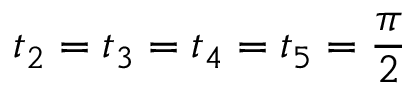Convert formula to latex. <formula><loc_0><loc_0><loc_500><loc_500>t _ { 2 } = t _ { 3 } = t _ { 4 } = t _ { 5 } = \frac { \pi } { 2 }</formula> 